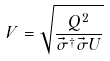<formula> <loc_0><loc_0><loc_500><loc_500>V = \sqrt { \frac { Q ^ { 2 } } { { \vec { \sigma } } ^ { \dagger } \vec { \sigma } U } }</formula> 